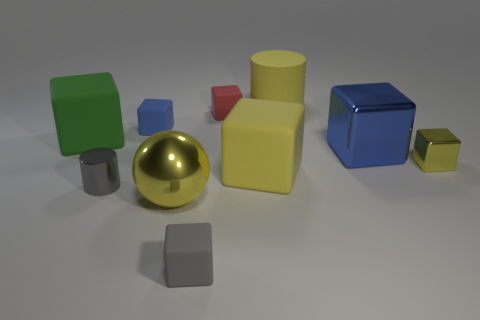There is a small object to the right of the red thing; is it the same color as the metal ball?
Make the answer very short. Yes. What is the color of the cylinder that is the same size as the red matte cube?
Provide a succinct answer. Gray. What is the big yellow thing that is both behind the large yellow ball and in front of the green object made of?
Ensure brevity in your answer.  Rubber. How many other things are the same size as the red thing?
Give a very brief answer. 4. There is a big matte object that is in front of the large matte object to the left of the gray matte object; is there a blue rubber block that is on the left side of it?
Offer a very short reply. Yes. Is the yellow cube left of the blue shiny object made of the same material as the large sphere?
Make the answer very short. No. What is the color of the small metal object that is the same shape as the small gray rubber thing?
Give a very brief answer. Yellow. Are there any other things that have the same shape as the big yellow shiny object?
Give a very brief answer. No. Are there an equal number of tiny red blocks that are in front of the red thing and red matte blocks?
Your answer should be very brief. No. There is a large yellow cube; are there any big matte blocks behind it?
Give a very brief answer. Yes. 